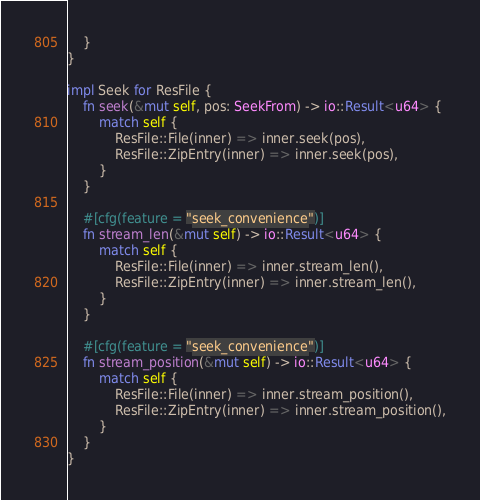Convert code to text. <code><loc_0><loc_0><loc_500><loc_500><_Rust_>    }
}

impl Seek for ResFile {
    fn seek(&mut self, pos: SeekFrom) -> io::Result<u64> {
        match self {
            ResFile::File(inner) => inner.seek(pos),
            ResFile::ZipEntry(inner) => inner.seek(pos),
        }
    }

    #[cfg(feature = "seek_convenience")]
    fn stream_len(&mut self) -> io::Result<u64> {
        match self {
            ResFile::File(inner) => inner.stream_len(),
            ResFile::ZipEntry(inner) => inner.stream_len(),
        }
    }

    #[cfg(feature = "seek_convenience")]
    fn stream_position(&mut self) -> io::Result<u64> {
        match self {
            ResFile::File(inner) => inner.stream_position(),
            ResFile::ZipEntry(inner) => inner.stream_position(),
        }
    }
}
</code> 